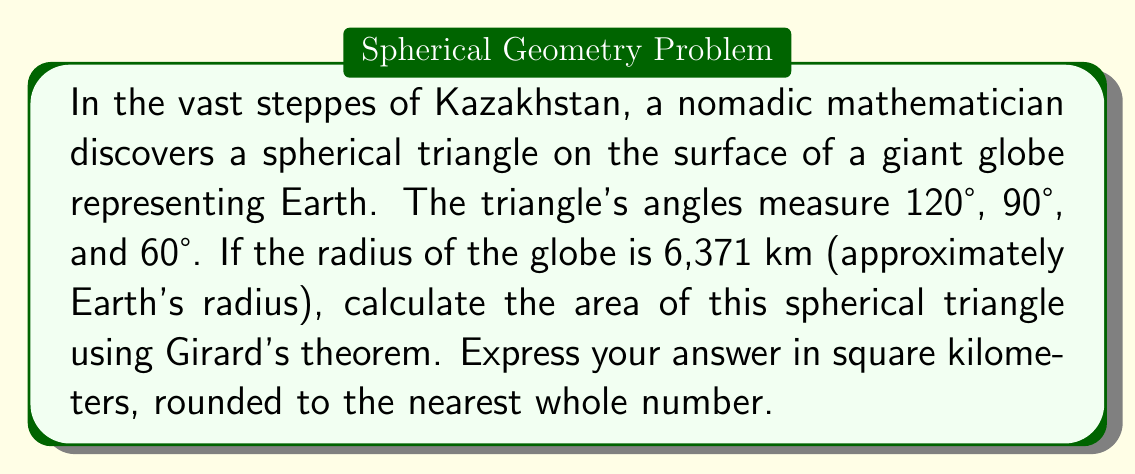Help me with this question. Let's approach this step-by-step using Girard's theorem:

1) Girard's theorem states that the area $A$ of a spherical triangle on a sphere of radius $r$ is given by:

   $$A = r^2(α + β + γ - π)$$

   where $α$, $β$, and $γ$ are the angles of the triangle in radians, and $π$ is pi.

2) We're given the angles in degrees: 120°, 90°, and 60°. Let's convert these to radians:
   
   $α = 120° = \frac{2π}{3}$ radians
   $β = 90° = \frac{π}{2}$ radians
   $γ = 60° = \frac{π}{3}$ radians

3) Now, let's sum these angles:

   $$\frac{2π}{3} + \frac{π}{2} + \frac{π}{3} = \frac{4π}{3} + \frac{3π}{6} = \frac{8π}{6} + \frac{3π}{6} = \frac{11π}{6}$$

4) Subtract $π$ from this sum:

   $$\frac{11π}{6} - π = \frac{11π}{6} - \frac{6π}{6} = \frac{5π}{6}$$

5) Now we can plug this into our formula, using $r = 6,371$ km:

   $$A = (6,371)^2 \cdot \frac{5π}{6}$$

6) Calculate:

   $$A = 40,589,641 \cdot \frac{5π}{6} ≈ 106,108,883.7 \text{ km}^2$$

7) Rounding to the nearest whole number:

   $$A ≈ 106,108,884 \text{ km}^2$$
Answer: 106,108,884 km² 